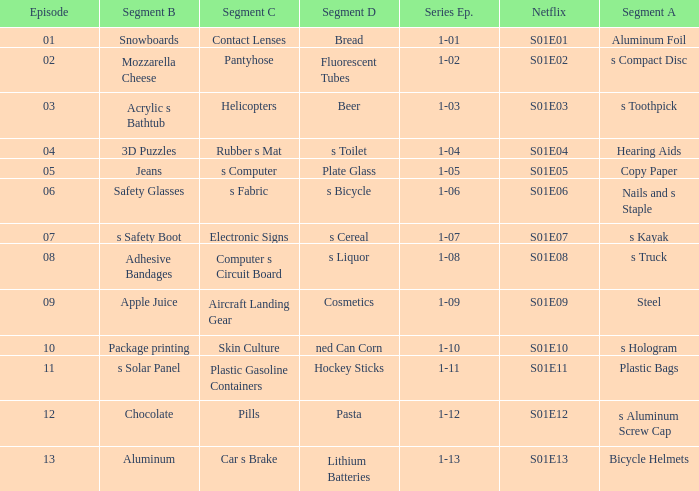What is the series episode number with a segment of D, and having fluorescent tubes? 1-02. 